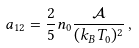<formula> <loc_0><loc_0><loc_500><loc_500>a _ { 1 2 } = \frac { 2 } { 5 } n _ { 0 } \frac { \mathcal { A } } { ( k _ { B } T _ { 0 } ) ^ { 2 } } \, ,</formula> 